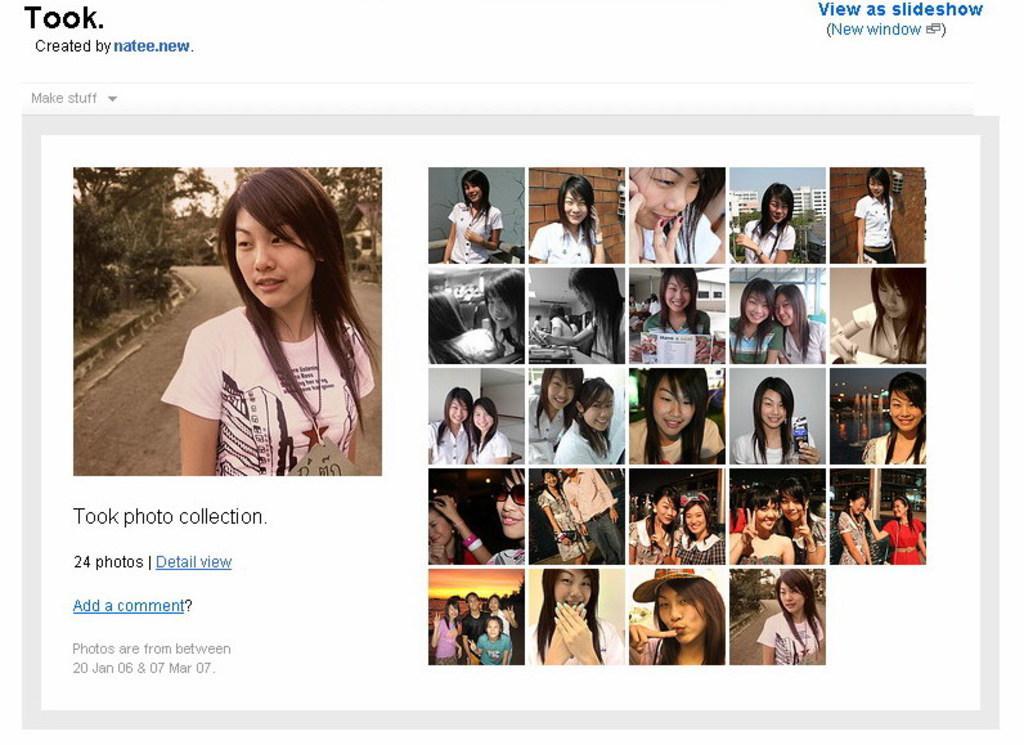In one or two sentences, can you explain what this image depicts? In this image we can see the screenshot in a system. In this image we can some pictures of a person and some text. 